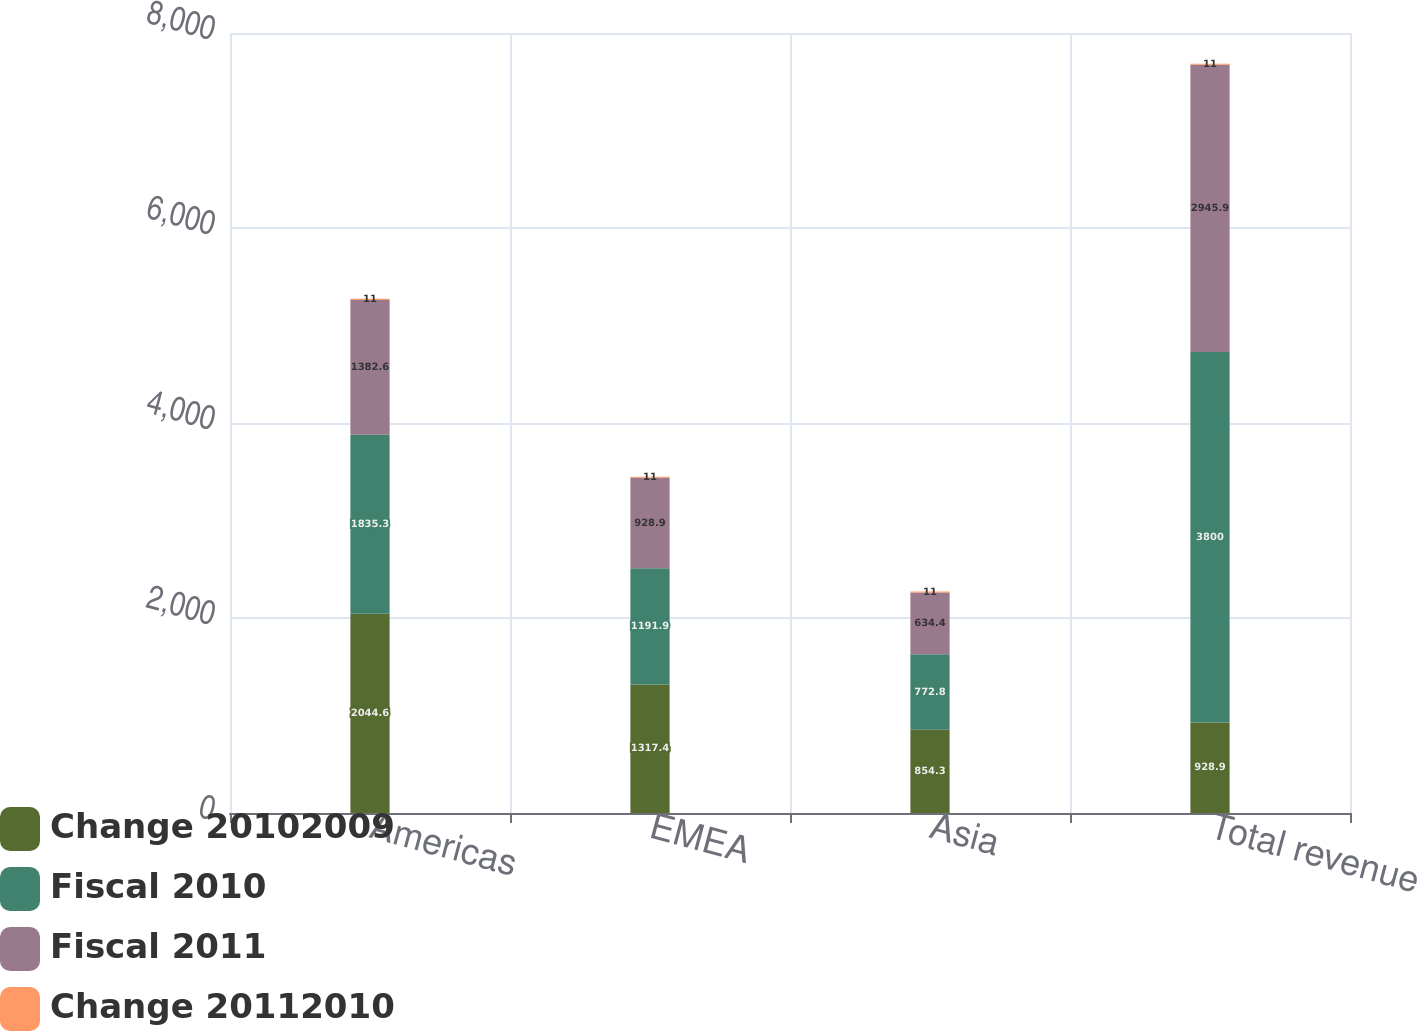Convert chart. <chart><loc_0><loc_0><loc_500><loc_500><stacked_bar_chart><ecel><fcel>Americas<fcel>EMEA<fcel>Asia<fcel>Total revenue<nl><fcel>Change 20102009<fcel>2044.6<fcel>1317.4<fcel>854.3<fcel>928.9<nl><fcel>Fiscal 2010<fcel>1835.3<fcel>1191.9<fcel>772.8<fcel>3800<nl><fcel>Fiscal 2011<fcel>1382.6<fcel>928.9<fcel>634.4<fcel>2945.9<nl><fcel>Change 20112010<fcel>11<fcel>11<fcel>11<fcel>11<nl></chart> 